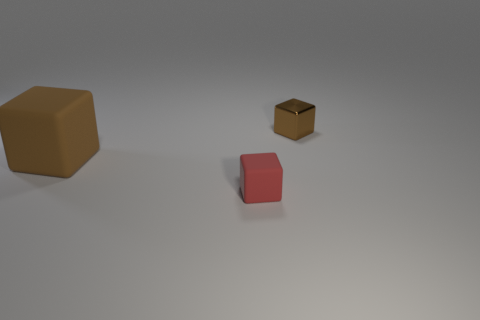What number of objects are blocks to the right of the small red rubber thing or small brown metal blocks?
Ensure brevity in your answer.  1. Is there anything else that has the same material as the red object?
Provide a succinct answer. Yes. How many objects are on the left side of the tiny brown shiny thing and right of the large cube?
Ensure brevity in your answer.  1. How many things are tiny brown metal cubes behind the brown rubber cube or objects to the left of the brown shiny cube?
Give a very brief answer. 3. There is a small rubber object in front of the brown rubber object; is its color the same as the small metal thing?
Provide a short and direct response. No. What number of other objects are there of the same size as the red rubber cube?
Your response must be concise. 1. Are the small brown block and the large brown thing made of the same material?
Offer a terse response. No. There is a tiny block in front of the matte cube on the left side of the tiny red matte object; what color is it?
Make the answer very short. Red. What is the size of the red matte object that is the same shape as the large brown rubber object?
Provide a succinct answer. Small. Does the shiny object have the same color as the big thing?
Provide a short and direct response. Yes. 